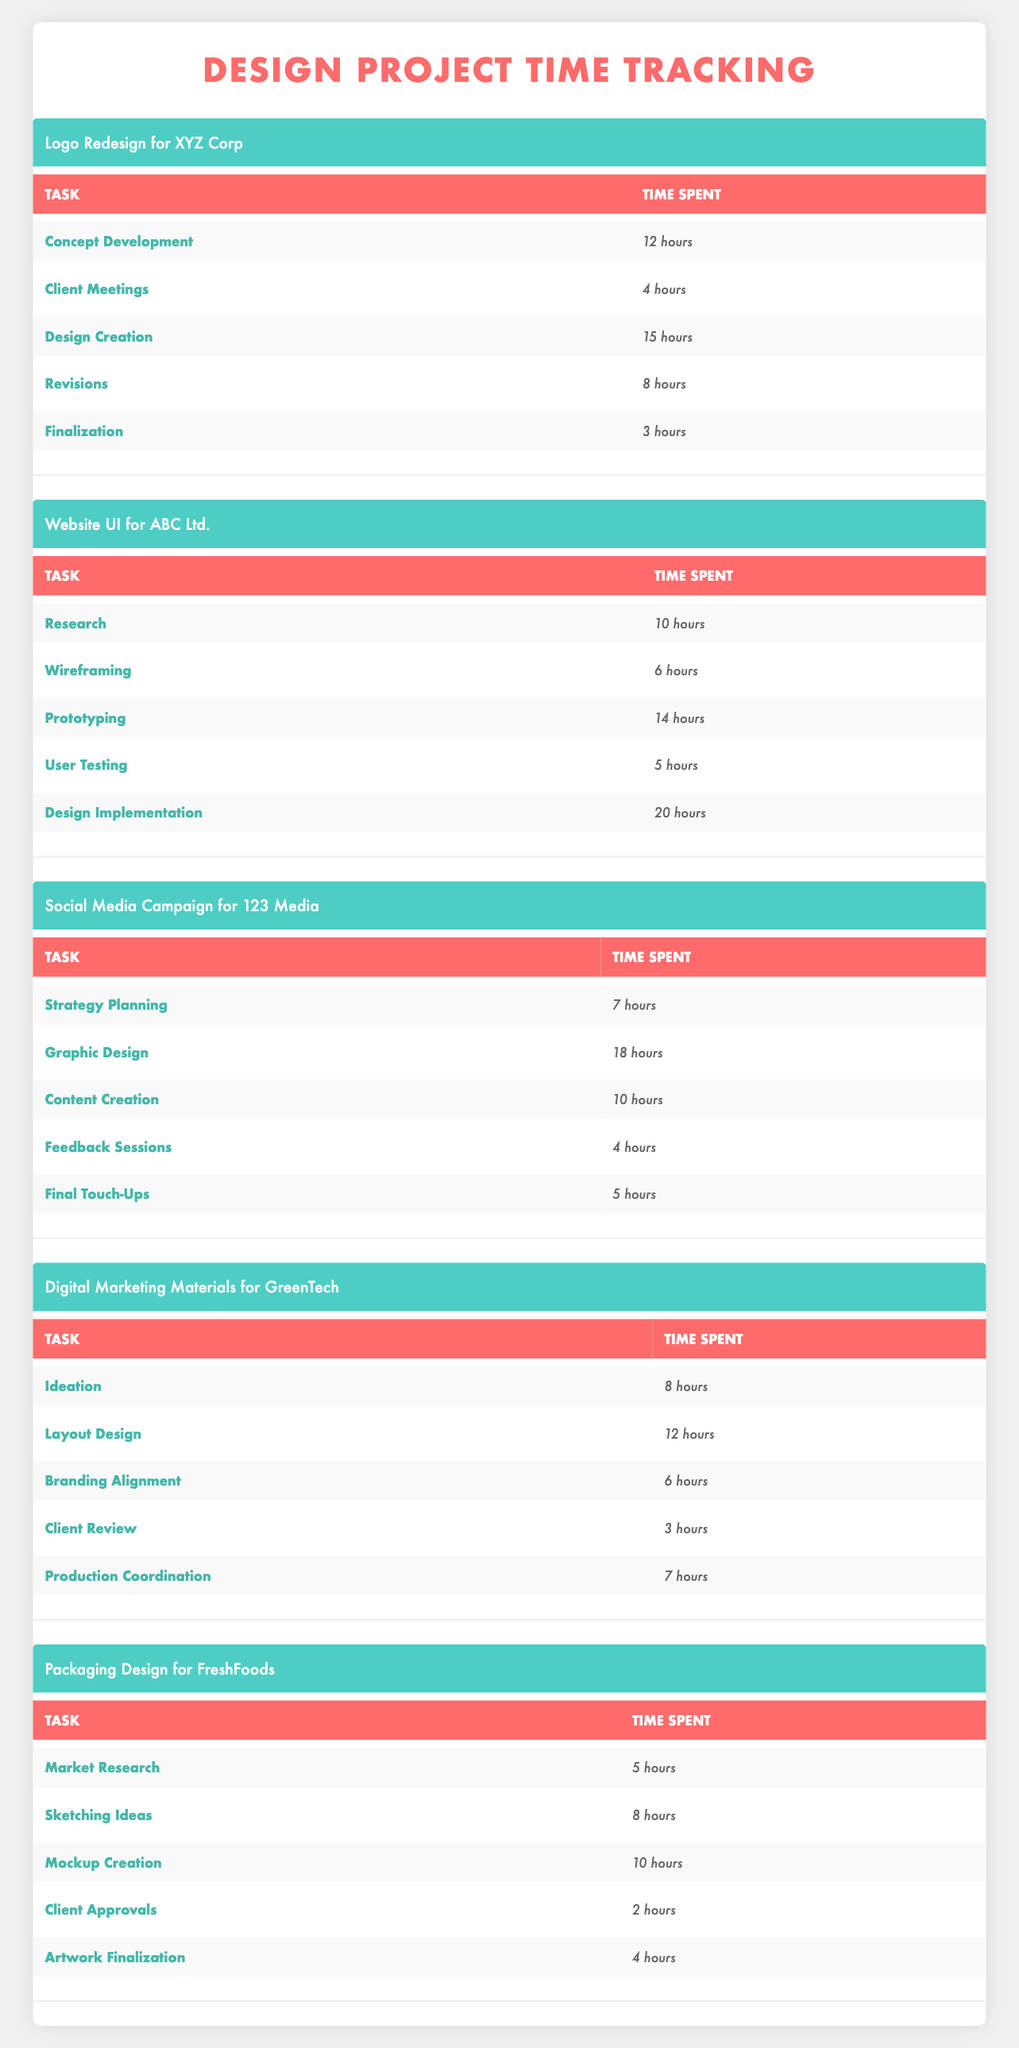What is the total time spent on the "Design Creation" task for the "Logo Redesign for XYZ Corp" project? The time spent on "Design Creation" in the "Logo Redesign for XYZ Corp" project is 15 hours. This can be directly observed in the table.
Answer: 15 hours What is the combined time spent on "Client Meetings" and "Revisions" for the "Logo Redesign for XYZ Corp"? The time spent on "Client Meetings" is 4 hours and on "Revisions" is 8 hours. Adding those together: 4 + 8 = 12 hours.
Answer: 12 hours Did the "Social Media Campaign for 123 Media" take longer than the "Digital Marketing Materials for GreenTech"? For "Social Media Campaign for 123 Media," the total time is 44 hours (7 + 18 + 10 + 4 + 5). For "Digital Marketing Materials for GreenTech," the total time is 36 hours (8 + 12 + 6 + 3 + 7). Since 44 hours is greater than 36, the answer is yes.
Answer: Yes What task took the most time in the "Website UI for ABC Ltd." project, and how many hours did it take? In the "Website UI for ABC Ltd." project, the task with the most time is "Design Implementation," which took 20 hours. This can be seen in the table as the highest value under that project.
Answer: Design Implementation, 20 hours What is the average time spent on all tasks for the "Packaging Design for FreshFoods"? The total time for "Packaging Design for FreshFoods" is 39 hours (5 + 8 + 10 + 2 + 4). There are 5 tasks in total. To find the average, divide the total time by the number of tasks: 39 / 5 = 7.8 hours.
Answer: 7.8 hours How much time was allocated to "Feedback Sessions" in the "Social Media Campaign for 123 Media"? "Feedback Sessions" in the "Social Media Campaign for 123 Media" project took 4 hours, as noted in the table.
Answer: 4 hours Is the time spent on "Market Research" in the "Packaging Design for FreshFoods" project greater than the time spent on "Client Review" in the "Digital Marketing Materials for GreenTech"? "Market Research" took 5 hours in the "Packaging Design for FreshFoods" project, while "Client Review" took 3 hours in the "Digital Marketing Materials for GreenTech." Since 5 is greater than 3, the answer is yes.
Answer: Yes How many total hours were spent on the "Design Creation" and "Prototyping" tasks across all projects? "Design Creation" in "Logo Redesign for XYZ Corp" took 15 hours, and "Prototyping" in "Website UI for ABC Ltd." took 14 hours. Adding these gives: 15 + 14 = 29 hours.
Answer: 29 hours What is the total time spent on the "Digital Marketing Materials for GreenTech"? The total time for the "Digital Marketing Materials for GreenTech" project is calculated as follows: 8 + 12 + 6 + 3 + 7 = 36 hours. This total is directly calculated from the data provided in the table.
Answer: 36 hours 